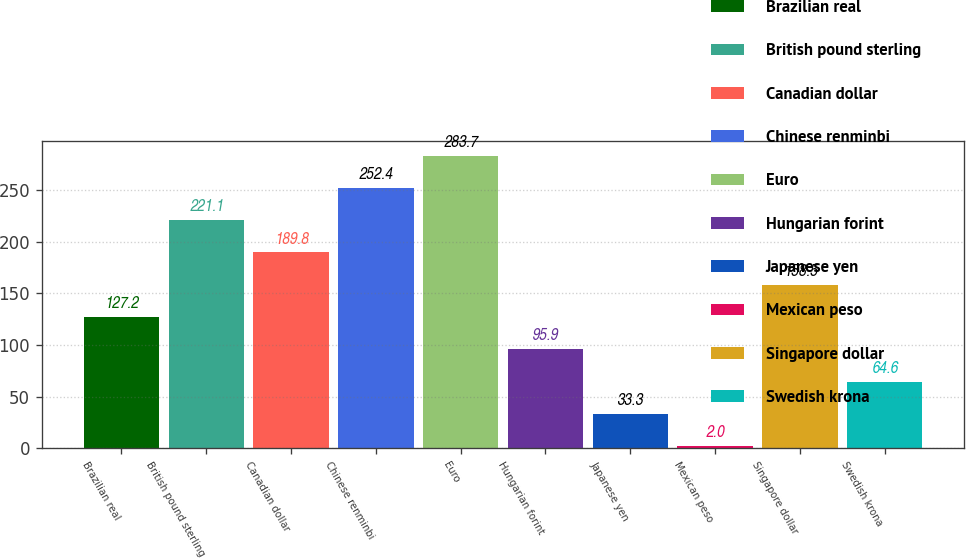Convert chart. <chart><loc_0><loc_0><loc_500><loc_500><bar_chart><fcel>Brazilian real<fcel>British pound sterling<fcel>Canadian dollar<fcel>Chinese renminbi<fcel>Euro<fcel>Hungarian forint<fcel>Japanese yen<fcel>Mexican peso<fcel>Singapore dollar<fcel>Swedish krona<nl><fcel>127.2<fcel>221.1<fcel>189.8<fcel>252.4<fcel>283.7<fcel>95.9<fcel>33.3<fcel>2<fcel>158.5<fcel>64.6<nl></chart> 